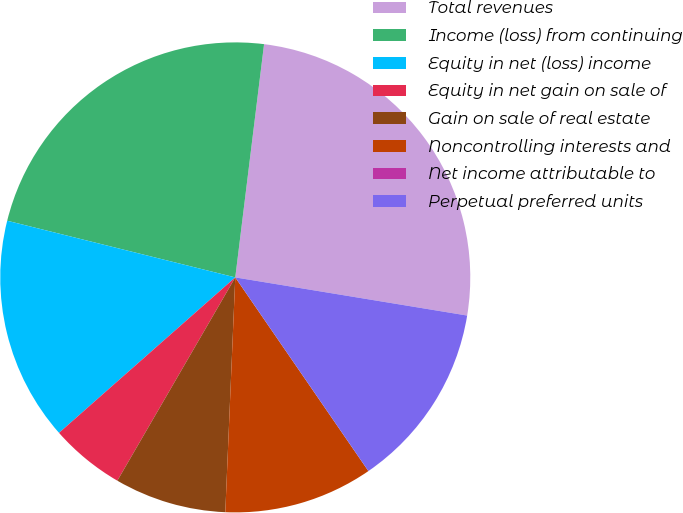Convert chart. <chart><loc_0><loc_0><loc_500><loc_500><pie_chart><fcel>Total revenues<fcel>Income (loss) from continuing<fcel>Equity in net (loss) income<fcel>Equity in net gain on sale of<fcel>Gain on sale of real estate<fcel>Noncontrolling interests and<fcel>Net income attributable to<fcel>Perpetual preferred units<nl><fcel>25.64%<fcel>23.08%<fcel>15.38%<fcel>5.13%<fcel>7.69%<fcel>10.26%<fcel>0.0%<fcel>12.82%<nl></chart> 